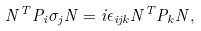Convert formula to latex. <formula><loc_0><loc_0><loc_500><loc_500>N ^ { T } P _ { i } \sigma _ { j } N = i \epsilon _ { i j k } N ^ { T } P _ { k } N ,</formula> 